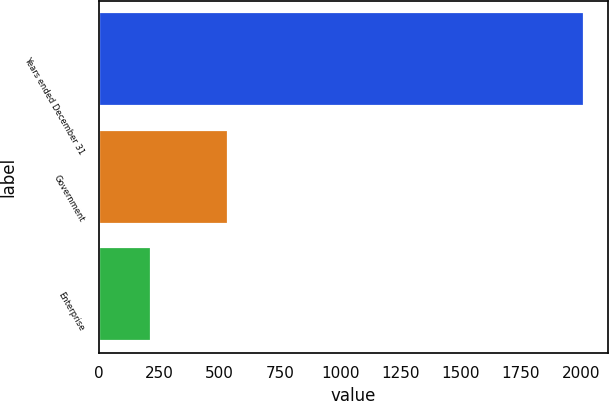<chart> <loc_0><loc_0><loc_500><loc_500><bar_chart><fcel>Years ended December 31<fcel>Government<fcel>Enterprise<nl><fcel>2010<fcel>534<fcel>217<nl></chart> 